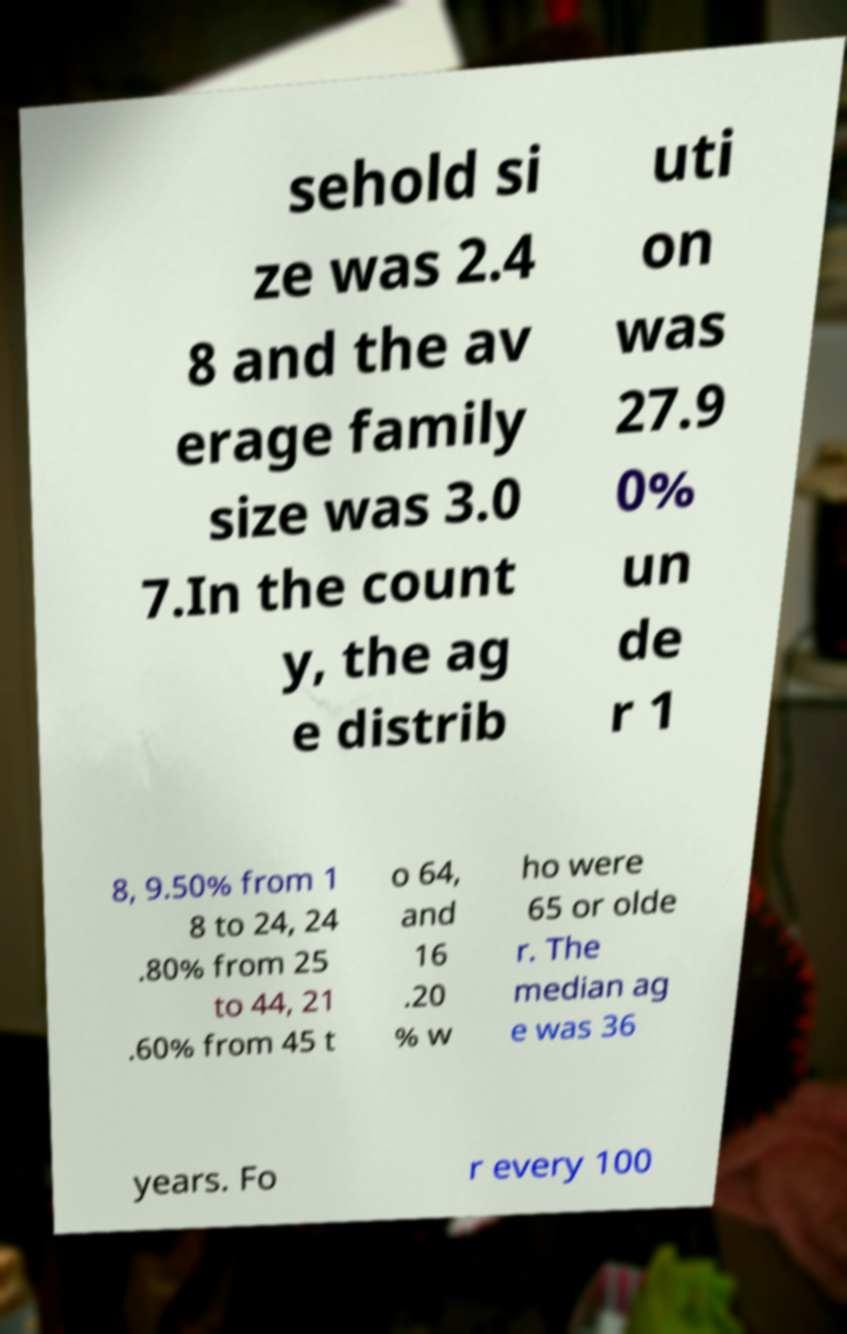I need the written content from this picture converted into text. Can you do that? sehold si ze was 2.4 8 and the av erage family size was 3.0 7.In the count y, the ag e distrib uti on was 27.9 0% un de r 1 8, 9.50% from 1 8 to 24, 24 .80% from 25 to 44, 21 .60% from 45 t o 64, and 16 .20 % w ho were 65 or olde r. The median ag e was 36 years. Fo r every 100 